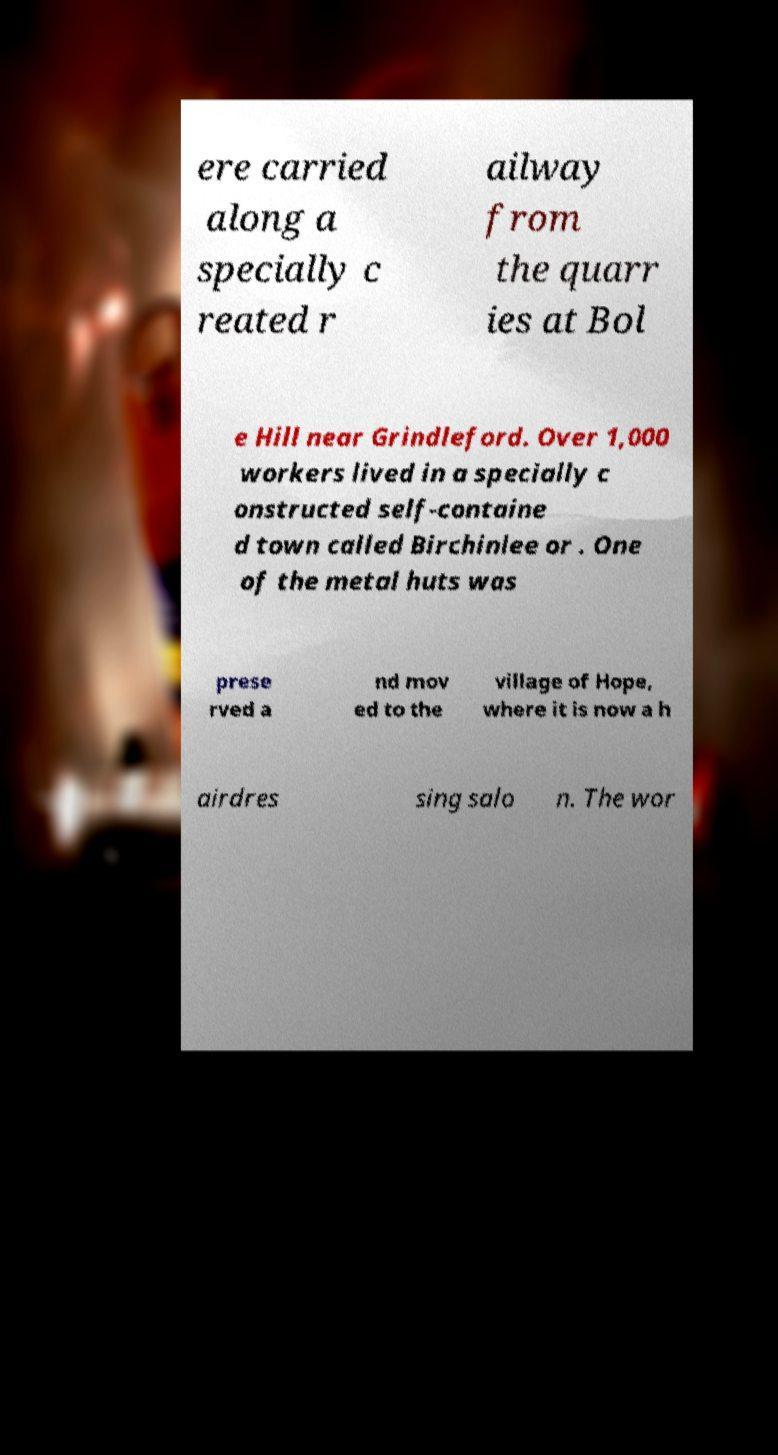Please identify and transcribe the text found in this image. ere carried along a specially c reated r ailway from the quarr ies at Bol e Hill near Grindleford. Over 1,000 workers lived in a specially c onstructed self-containe d town called Birchinlee or . One of the metal huts was prese rved a nd mov ed to the village of Hope, where it is now a h airdres sing salo n. The wor 